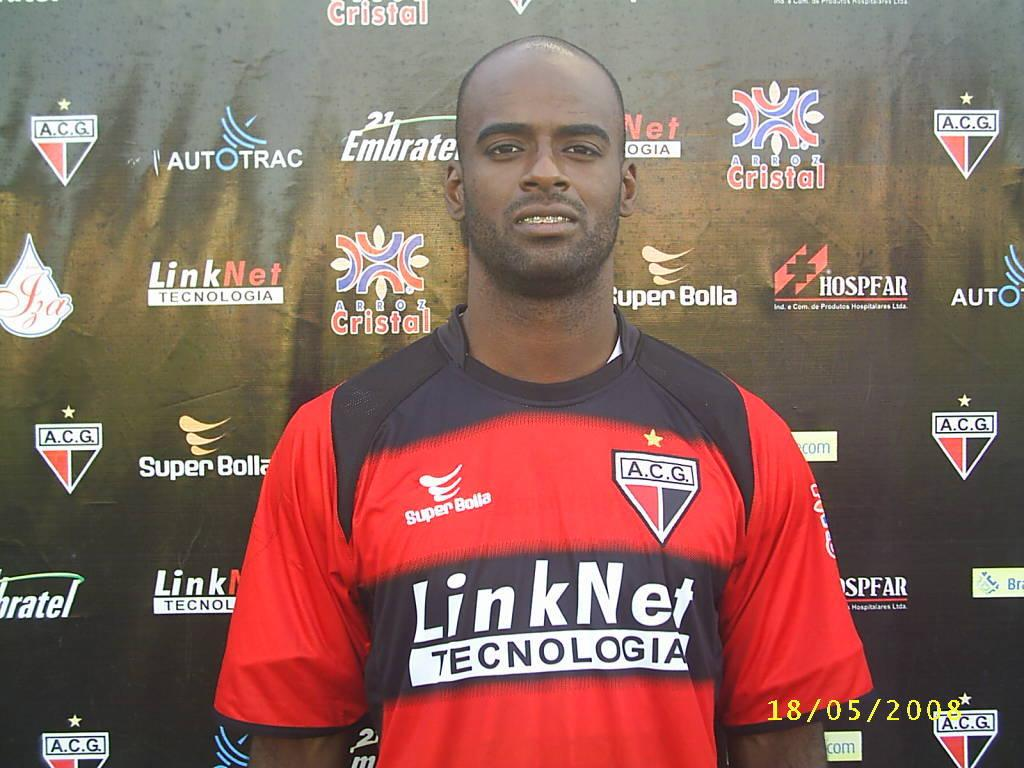<image>
Present a compact description of the photo's key features. athlete posing with sponsors backdrop, Link Net Technolgia on the shirt 